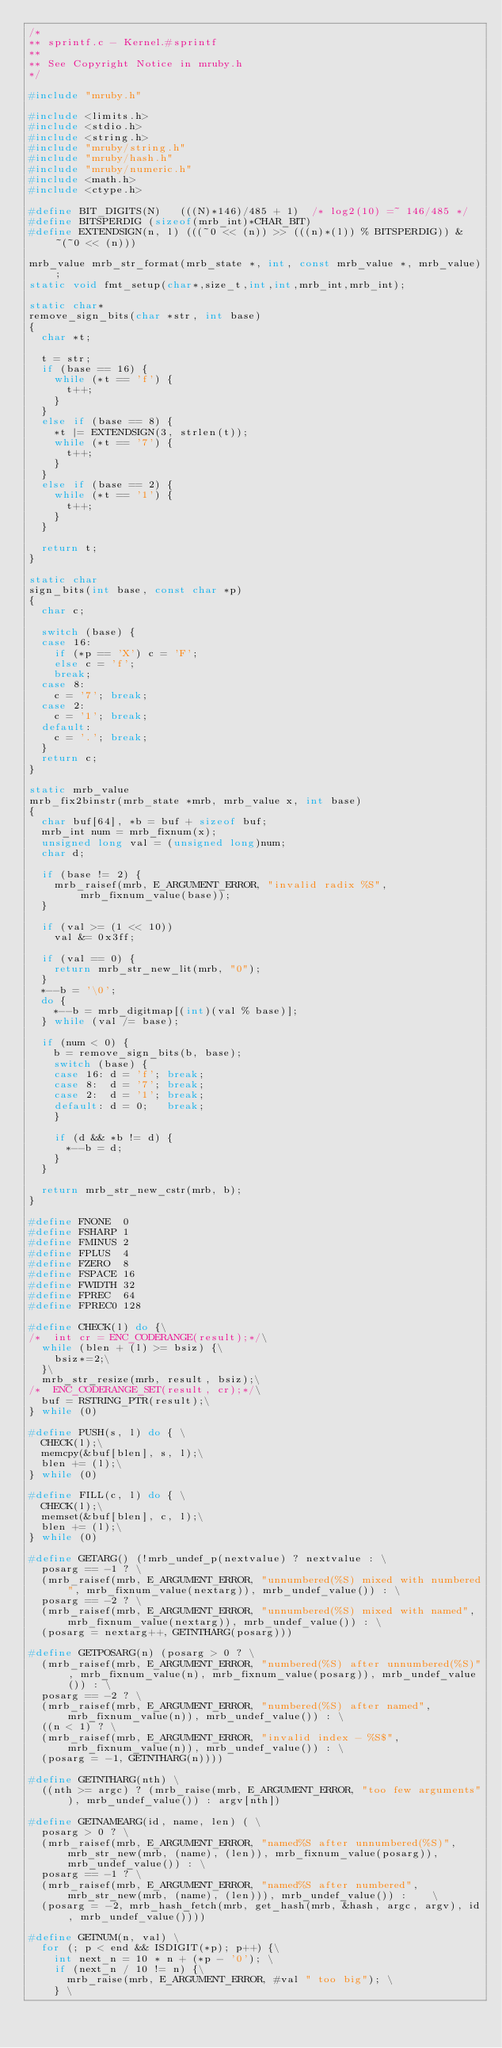<code> <loc_0><loc_0><loc_500><loc_500><_C_>/*
** sprintf.c - Kernel.#sprintf
**
** See Copyright Notice in mruby.h
*/

#include "mruby.h"

#include <limits.h>
#include <stdio.h>
#include <string.h>
#include "mruby/string.h"
#include "mruby/hash.h"
#include "mruby/numeric.h"
#include <math.h>
#include <ctype.h>

#define BIT_DIGITS(N)   (((N)*146)/485 + 1)  /* log2(10) =~ 146/485 */
#define BITSPERDIG (sizeof(mrb_int)*CHAR_BIT)
#define EXTENDSIGN(n, l) (((~0 << (n)) >> (((n)*(l)) % BITSPERDIG)) & ~(~0 << (n)))

mrb_value mrb_str_format(mrb_state *, int, const mrb_value *, mrb_value);
static void fmt_setup(char*,size_t,int,int,mrb_int,mrb_int);

static char*
remove_sign_bits(char *str, int base)
{
  char *t;

  t = str;
  if (base == 16) {
    while (*t == 'f') {
      t++;
    }
  }
  else if (base == 8) {
    *t |= EXTENDSIGN(3, strlen(t));
    while (*t == '7') {
      t++;
    }
  }
  else if (base == 2) {
    while (*t == '1') {
      t++;
    }
  }

  return t;
}

static char
sign_bits(int base, const char *p)
{
  char c;

  switch (base) {
  case 16:
    if (*p == 'X') c = 'F';
    else c = 'f';
    break;
  case 8:
    c = '7'; break;
  case 2:
    c = '1'; break;
  default:
    c = '.'; break;
  }
  return c;
}

static mrb_value
mrb_fix2binstr(mrb_state *mrb, mrb_value x, int base)
{
  char buf[64], *b = buf + sizeof buf;
  mrb_int num = mrb_fixnum(x);
  unsigned long val = (unsigned long)num;
  char d;

  if (base != 2) {
    mrb_raisef(mrb, E_ARGUMENT_ERROR, "invalid radix %S", mrb_fixnum_value(base));
  }

  if (val >= (1 << 10))
    val &= 0x3ff;

  if (val == 0) {
    return mrb_str_new_lit(mrb, "0");
  }
  *--b = '\0';
  do {
    *--b = mrb_digitmap[(int)(val % base)];
  } while (val /= base);

  if (num < 0) {
    b = remove_sign_bits(b, base);
    switch (base) {
    case 16: d = 'f'; break;
    case 8:  d = '7'; break;
    case 2:  d = '1'; break;
    default: d = 0;   break;
    }

    if (d && *b != d) {
      *--b = d;
    }
  }

  return mrb_str_new_cstr(mrb, b);
}

#define FNONE  0
#define FSHARP 1
#define FMINUS 2
#define FPLUS  4
#define FZERO  8
#define FSPACE 16
#define FWIDTH 32
#define FPREC  64
#define FPREC0 128

#define CHECK(l) do {\
/*  int cr = ENC_CODERANGE(result);*/\
  while (blen + (l) >= bsiz) {\
    bsiz*=2;\
  }\
  mrb_str_resize(mrb, result, bsiz);\
/*  ENC_CODERANGE_SET(result, cr);*/\
  buf = RSTRING_PTR(result);\
} while (0)

#define PUSH(s, l) do { \
  CHECK(l);\
  memcpy(&buf[blen], s, l);\
  blen += (l);\
} while (0)

#define FILL(c, l) do { \
  CHECK(l);\
  memset(&buf[blen], c, l);\
  blen += (l);\
} while (0)

#define GETARG() (!mrb_undef_p(nextvalue) ? nextvalue : \
  posarg == -1 ? \
  (mrb_raisef(mrb, E_ARGUMENT_ERROR, "unnumbered(%S) mixed with numbered", mrb_fixnum_value(nextarg)), mrb_undef_value()) : \
  posarg == -2 ? \
  (mrb_raisef(mrb, E_ARGUMENT_ERROR, "unnumbered(%S) mixed with named", mrb_fixnum_value(nextarg)), mrb_undef_value()) : \
  (posarg = nextarg++, GETNTHARG(posarg)))

#define GETPOSARG(n) (posarg > 0 ? \
  (mrb_raisef(mrb, E_ARGUMENT_ERROR, "numbered(%S) after unnumbered(%S)", mrb_fixnum_value(n), mrb_fixnum_value(posarg)), mrb_undef_value()) : \
  posarg == -2 ? \
  (mrb_raisef(mrb, E_ARGUMENT_ERROR, "numbered(%S) after named", mrb_fixnum_value(n)), mrb_undef_value()) : \
  ((n < 1) ? \
  (mrb_raisef(mrb, E_ARGUMENT_ERROR, "invalid index - %S$", mrb_fixnum_value(n)), mrb_undef_value()) : \
  (posarg = -1, GETNTHARG(n))))

#define GETNTHARG(nth) \
  ((nth >= argc) ? (mrb_raise(mrb, E_ARGUMENT_ERROR, "too few arguments"), mrb_undef_value()) : argv[nth])

#define GETNAMEARG(id, name, len) ( \
  posarg > 0 ? \
  (mrb_raisef(mrb, E_ARGUMENT_ERROR, "named%S after unnumbered(%S)", mrb_str_new(mrb, (name), (len)), mrb_fixnum_value(posarg)), mrb_undef_value()) : \
  posarg == -1 ? \
  (mrb_raisef(mrb, E_ARGUMENT_ERROR, "named%S after numbered", mrb_str_new(mrb, (name), (len))), mrb_undef_value()) :    \
  (posarg = -2, mrb_hash_fetch(mrb, get_hash(mrb, &hash, argc, argv), id, mrb_undef_value())))

#define GETNUM(n, val) \
  for (; p < end && ISDIGIT(*p); p++) {\
    int next_n = 10 * n + (*p - '0'); \
    if (next_n / 10 != n) {\
      mrb_raise(mrb, E_ARGUMENT_ERROR, #val " too big"); \
    } \</code> 